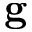<formula> <loc_0><loc_0><loc_500><loc_500>g</formula> 